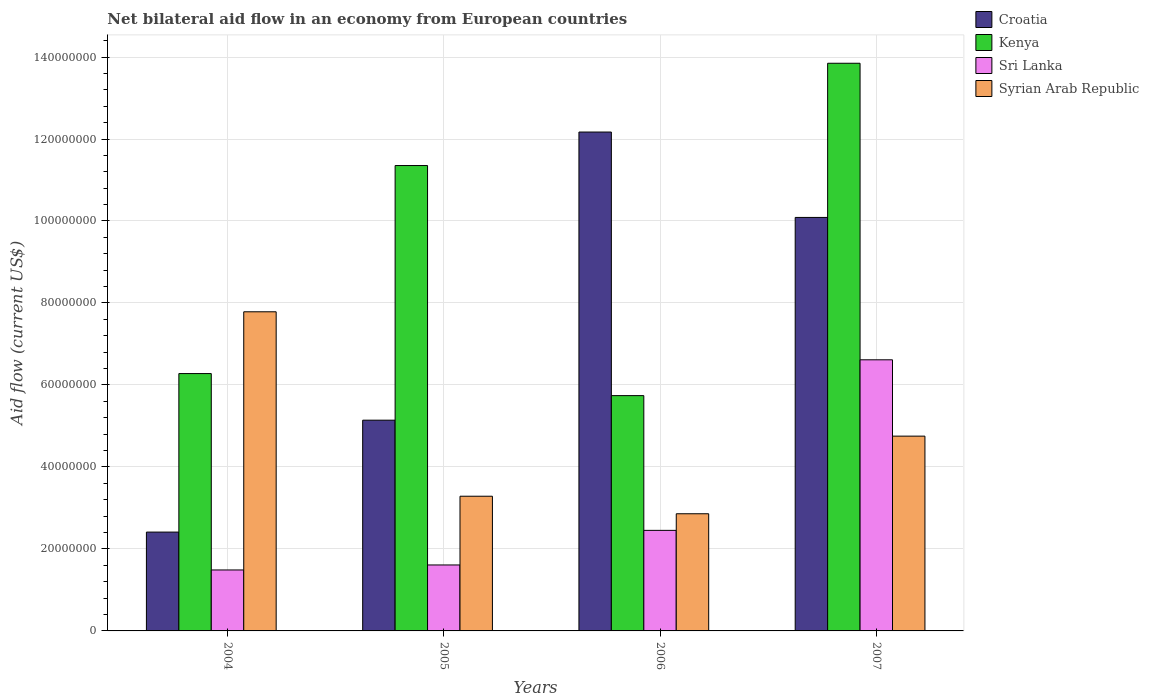How many groups of bars are there?
Provide a short and direct response. 4. Are the number of bars per tick equal to the number of legend labels?
Your answer should be very brief. Yes. Are the number of bars on each tick of the X-axis equal?
Your response must be concise. Yes. How many bars are there on the 1st tick from the right?
Your response must be concise. 4. What is the net bilateral aid flow in Kenya in 2006?
Ensure brevity in your answer.  5.74e+07. Across all years, what is the maximum net bilateral aid flow in Syrian Arab Republic?
Provide a succinct answer. 7.78e+07. Across all years, what is the minimum net bilateral aid flow in Croatia?
Ensure brevity in your answer.  2.41e+07. In which year was the net bilateral aid flow in Croatia maximum?
Keep it short and to the point. 2006. In which year was the net bilateral aid flow in Croatia minimum?
Provide a succinct answer. 2004. What is the total net bilateral aid flow in Croatia in the graph?
Provide a succinct answer. 2.98e+08. What is the difference between the net bilateral aid flow in Kenya in 2005 and that in 2007?
Provide a succinct answer. -2.50e+07. What is the difference between the net bilateral aid flow in Kenya in 2005 and the net bilateral aid flow in Syrian Arab Republic in 2006?
Make the answer very short. 8.50e+07. What is the average net bilateral aid flow in Sri Lanka per year?
Provide a succinct answer. 3.04e+07. In the year 2006, what is the difference between the net bilateral aid flow in Kenya and net bilateral aid flow in Syrian Arab Republic?
Your answer should be compact. 2.88e+07. In how many years, is the net bilateral aid flow in Croatia greater than 4000000 US$?
Provide a succinct answer. 4. What is the ratio of the net bilateral aid flow in Croatia in 2005 to that in 2006?
Give a very brief answer. 0.42. Is the net bilateral aid flow in Kenya in 2005 less than that in 2007?
Give a very brief answer. Yes. Is the difference between the net bilateral aid flow in Kenya in 2005 and 2007 greater than the difference between the net bilateral aid flow in Syrian Arab Republic in 2005 and 2007?
Keep it short and to the point. No. What is the difference between the highest and the second highest net bilateral aid flow in Sri Lanka?
Offer a very short reply. 4.16e+07. What is the difference between the highest and the lowest net bilateral aid flow in Croatia?
Your response must be concise. 9.76e+07. What does the 4th bar from the left in 2007 represents?
Make the answer very short. Syrian Arab Republic. What does the 2nd bar from the right in 2005 represents?
Offer a terse response. Sri Lanka. Is it the case that in every year, the sum of the net bilateral aid flow in Syrian Arab Republic and net bilateral aid flow in Sri Lanka is greater than the net bilateral aid flow in Croatia?
Make the answer very short. No. How many years are there in the graph?
Give a very brief answer. 4. What is the difference between two consecutive major ticks on the Y-axis?
Keep it short and to the point. 2.00e+07. Are the values on the major ticks of Y-axis written in scientific E-notation?
Provide a short and direct response. No. Does the graph contain grids?
Offer a very short reply. Yes. Where does the legend appear in the graph?
Ensure brevity in your answer.  Top right. How are the legend labels stacked?
Your answer should be very brief. Vertical. What is the title of the graph?
Make the answer very short. Net bilateral aid flow in an economy from European countries. What is the label or title of the X-axis?
Make the answer very short. Years. What is the Aid flow (current US$) in Croatia in 2004?
Give a very brief answer. 2.41e+07. What is the Aid flow (current US$) in Kenya in 2004?
Give a very brief answer. 6.28e+07. What is the Aid flow (current US$) of Sri Lanka in 2004?
Offer a very short reply. 1.49e+07. What is the Aid flow (current US$) of Syrian Arab Republic in 2004?
Ensure brevity in your answer.  7.78e+07. What is the Aid flow (current US$) of Croatia in 2005?
Your answer should be compact. 5.14e+07. What is the Aid flow (current US$) of Kenya in 2005?
Make the answer very short. 1.14e+08. What is the Aid flow (current US$) in Sri Lanka in 2005?
Keep it short and to the point. 1.61e+07. What is the Aid flow (current US$) in Syrian Arab Republic in 2005?
Offer a terse response. 3.29e+07. What is the Aid flow (current US$) of Croatia in 2006?
Keep it short and to the point. 1.22e+08. What is the Aid flow (current US$) of Kenya in 2006?
Give a very brief answer. 5.74e+07. What is the Aid flow (current US$) of Sri Lanka in 2006?
Offer a very short reply. 2.45e+07. What is the Aid flow (current US$) in Syrian Arab Republic in 2006?
Your answer should be compact. 2.86e+07. What is the Aid flow (current US$) of Croatia in 2007?
Give a very brief answer. 1.01e+08. What is the Aid flow (current US$) in Kenya in 2007?
Your answer should be compact. 1.38e+08. What is the Aid flow (current US$) in Sri Lanka in 2007?
Provide a short and direct response. 6.61e+07. What is the Aid flow (current US$) of Syrian Arab Republic in 2007?
Keep it short and to the point. 4.75e+07. Across all years, what is the maximum Aid flow (current US$) in Croatia?
Your answer should be compact. 1.22e+08. Across all years, what is the maximum Aid flow (current US$) in Kenya?
Your answer should be very brief. 1.38e+08. Across all years, what is the maximum Aid flow (current US$) of Sri Lanka?
Keep it short and to the point. 6.61e+07. Across all years, what is the maximum Aid flow (current US$) of Syrian Arab Republic?
Make the answer very short. 7.78e+07. Across all years, what is the minimum Aid flow (current US$) of Croatia?
Provide a succinct answer. 2.41e+07. Across all years, what is the minimum Aid flow (current US$) of Kenya?
Ensure brevity in your answer.  5.74e+07. Across all years, what is the minimum Aid flow (current US$) in Sri Lanka?
Your response must be concise. 1.49e+07. Across all years, what is the minimum Aid flow (current US$) of Syrian Arab Republic?
Your response must be concise. 2.86e+07. What is the total Aid flow (current US$) in Croatia in the graph?
Provide a succinct answer. 2.98e+08. What is the total Aid flow (current US$) of Kenya in the graph?
Provide a succinct answer. 3.72e+08. What is the total Aid flow (current US$) in Sri Lanka in the graph?
Your response must be concise. 1.22e+08. What is the total Aid flow (current US$) of Syrian Arab Republic in the graph?
Provide a short and direct response. 1.87e+08. What is the difference between the Aid flow (current US$) of Croatia in 2004 and that in 2005?
Offer a terse response. -2.73e+07. What is the difference between the Aid flow (current US$) in Kenya in 2004 and that in 2005?
Provide a succinct answer. -5.08e+07. What is the difference between the Aid flow (current US$) of Sri Lanka in 2004 and that in 2005?
Keep it short and to the point. -1.22e+06. What is the difference between the Aid flow (current US$) in Syrian Arab Republic in 2004 and that in 2005?
Offer a terse response. 4.50e+07. What is the difference between the Aid flow (current US$) in Croatia in 2004 and that in 2006?
Keep it short and to the point. -9.76e+07. What is the difference between the Aid flow (current US$) in Kenya in 2004 and that in 2006?
Your response must be concise. 5.38e+06. What is the difference between the Aid flow (current US$) of Sri Lanka in 2004 and that in 2006?
Offer a terse response. -9.66e+06. What is the difference between the Aid flow (current US$) of Syrian Arab Republic in 2004 and that in 2006?
Make the answer very short. 4.93e+07. What is the difference between the Aid flow (current US$) in Croatia in 2004 and that in 2007?
Provide a short and direct response. -7.68e+07. What is the difference between the Aid flow (current US$) in Kenya in 2004 and that in 2007?
Your answer should be compact. -7.57e+07. What is the difference between the Aid flow (current US$) in Sri Lanka in 2004 and that in 2007?
Your answer should be compact. -5.13e+07. What is the difference between the Aid flow (current US$) of Syrian Arab Republic in 2004 and that in 2007?
Your response must be concise. 3.03e+07. What is the difference between the Aid flow (current US$) in Croatia in 2005 and that in 2006?
Make the answer very short. -7.03e+07. What is the difference between the Aid flow (current US$) in Kenya in 2005 and that in 2006?
Ensure brevity in your answer.  5.61e+07. What is the difference between the Aid flow (current US$) in Sri Lanka in 2005 and that in 2006?
Give a very brief answer. -8.44e+06. What is the difference between the Aid flow (current US$) in Syrian Arab Republic in 2005 and that in 2006?
Your answer should be compact. 4.28e+06. What is the difference between the Aid flow (current US$) of Croatia in 2005 and that in 2007?
Keep it short and to the point. -4.95e+07. What is the difference between the Aid flow (current US$) of Kenya in 2005 and that in 2007?
Provide a succinct answer. -2.50e+07. What is the difference between the Aid flow (current US$) in Sri Lanka in 2005 and that in 2007?
Provide a succinct answer. -5.00e+07. What is the difference between the Aid flow (current US$) of Syrian Arab Republic in 2005 and that in 2007?
Your answer should be very brief. -1.47e+07. What is the difference between the Aid flow (current US$) in Croatia in 2006 and that in 2007?
Offer a terse response. 2.08e+07. What is the difference between the Aid flow (current US$) of Kenya in 2006 and that in 2007?
Your answer should be compact. -8.11e+07. What is the difference between the Aid flow (current US$) in Sri Lanka in 2006 and that in 2007?
Give a very brief answer. -4.16e+07. What is the difference between the Aid flow (current US$) in Syrian Arab Republic in 2006 and that in 2007?
Your response must be concise. -1.89e+07. What is the difference between the Aid flow (current US$) of Croatia in 2004 and the Aid flow (current US$) of Kenya in 2005?
Your response must be concise. -8.94e+07. What is the difference between the Aid flow (current US$) of Croatia in 2004 and the Aid flow (current US$) of Sri Lanka in 2005?
Make the answer very short. 8.02e+06. What is the difference between the Aid flow (current US$) of Croatia in 2004 and the Aid flow (current US$) of Syrian Arab Republic in 2005?
Offer a terse response. -8.75e+06. What is the difference between the Aid flow (current US$) of Kenya in 2004 and the Aid flow (current US$) of Sri Lanka in 2005?
Give a very brief answer. 4.67e+07. What is the difference between the Aid flow (current US$) of Kenya in 2004 and the Aid flow (current US$) of Syrian Arab Republic in 2005?
Provide a succinct answer. 2.99e+07. What is the difference between the Aid flow (current US$) in Sri Lanka in 2004 and the Aid flow (current US$) in Syrian Arab Republic in 2005?
Offer a terse response. -1.80e+07. What is the difference between the Aid flow (current US$) in Croatia in 2004 and the Aid flow (current US$) in Kenya in 2006?
Offer a terse response. -3.33e+07. What is the difference between the Aid flow (current US$) of Croatia in 2004 and the Aid flow (current US$) of Sri Lanka in 2006?
Give a very brief answer. -4.20e+05. What is the difference between the Aid flow (current US$) of Croatia in 2004 and the Aid flow (current US$) of Syrian Arab Republic in 2006?
Your answer should be compact. -4.47e+06. What is the difference between the Aid flow (current US$) in Kenya in 2004 and the Aid flow (current US$) in Sri Lanka in 2006?
Your response must be concise. 3.82e+07. What is the difference between the Aid flow (current US$) of Kenya in 2004 and the Aid flow (current US$) of Syrian Arab Republic in 2006?
Make the answer very short. 3.42e+07. What is the difference between the Aid flow (current US$) of Sri Lanka in 2004 and the Aid flow (current US$) of Syrian Arab Republic in 2006?
Offer a terse response. -1.37e+07. What is the difference between the Aid flow (current US$) in Croatia in 2004 and the Aid flow (current US$) in Kenya in 2007?
Make the answer very short. -1.14e+08. What is the difference between the Aid flow (current US$) of Croatia in 2004 and the Aid flow (current US$) of Sri Lanka in 2007?
Give a very brief answer. -4.20e+07. What is the difference between the Aid flow (current US$) of Croatia in 2004 and the Aid flow (current US$) of Syrian Arab Republic in 2007?
Ensure brevity in your answer.  -2.34e+07. What is the difference between the Aid flow (current US$) in Kenya in 2004 and the Aid flow (current US$) in Sri Lanka in 2007?
Your answer should be very brief. -3.36e+06. What is the difference between the Aid flow (current US$) of Kenya in 2004 and the Aid flow (current US$) of Syrian Arab Republic in 2007?
Your answer should be very brief. 1.53e+07. What is the difference between the Aid flow (current US$) of Sri Lanka in 2004 and the Aid flow (current US$) of Syrian Arab Republic in 2007?
Your answer should be very brief. -3.26e+07. What is the difference between the Aid flow (current US$) in Croatia in 2005 and the Aid flow (current US$) in Kenya in 2006?
Your answer should be very brief. -5.99e+06. What is the difference between the Aid flow (current US$) of Croatia in 2005 and the Aid flow (current US$) of Sri Lanka in 2006?
Your response must be concise. 2.69e+07. What is the difference between the Aid flow (current US$) in Croatia in 2005 and the Aid flow (current US$) in Syrian Arab Republic in 2006?
Ensure brevity in your answer.  2.28e+07. What is the difference between the Aid flow (current US$) of Kenya in 2005 and the Aid flow (current US$) of Sri Lanka in 2006?
Your answer should be compact. 8.90e+07. What is the difference between the Aid flow (current US$) in Kenya in 2005 and the Aid flow (current US$) in Syrian Arab Republic in 2006?
Offer a very short reply. 8.50e+07. What is the difference between the Aid flow (current US$) of Sri Lanka in 2005 and the Aid flow (current US$) of Syrian Arab Republic in 2006?
Keep it short and to the point. -1.25e+07. What is the difference between the Aid flow (current US$) of Croatia in 2005 and the Aid flow (current US$) of Kenya in 2007?
Provide a succinct answer. -8.71e+07. What is the difference between the Aid flow (current US$) of Croatia in 2005 and the Aid flow (current US$) of Sri Lanka in 2007?
Your response must be concise. -1.47e+07. What is the difference between the Aid flow (current US$) in Croatia in 2005 and the Aid flow (current US$) in Syrian Arab Republic in 2007?
Ensure brevity in your answer.  3.89e+06. What is the difference between the Aid flow (current US$) in Kenya in 2005 and the Aid flow (current US$) in Sri Lanka in 2007?
Offer a very short reply. 4.74e+07. What is the difference between the Aid flow (current US$) of Kenya in 2005 and the Aid flow (current US$) of Syrian Arab Republic in 2007?
Provide a succinct answer. 6.60e+07. What is the difference between the Aid flow (current US$) of Sri Lanka in 2005 and the Aid flow (current US$) of Syrian Arab Republic in 2007?
Ensure brevity in your answer.  -3.14e+07. What is the difference between the Aid flow (current US$) in Croatia in 2006 and the Aid flow (current US$) in Kenya in 2007?
Ensure brevity in your answer.  -1.68e+07. What is the difference between the Aid flow (current US$) in Croatia in 2006 and the Aid flow (current US$) in Sri Lanka in 2007?
Your answer should be compact. 5.56e+07. What is the difference between the Aid flow (current US$) of Croatia in 2006 and the Aid flow (current US$) of Syrian Arab Republic in 2007?
Offer a very short reply. 7.42e+07. What is the difference between the Aid flow (current US$) in Kenya in 2006 and the Aid flow (current US$) in Sri Lanka in 2007?
Provide a succinct answer. -8.74e+06. What is the difference between the Aid flow (current US$) of Kenya in 2006 and the Aid flow (current US$) of Syrian Arab Republic in 2007?
Keep it short and to the point. 9.88e+06. What is the difference between the Aid flow (current US$) in Sri Lanka in 2006 and the Aid flow (current US$) in Syrian Arab Republic in 2007?
Offer a terse response. -2.30e+07. What is the average Aid flow (current US$) in Croatia per year?
Offer a very short reply. 7.45e+07. What is the average Aid flow (current US$) in Kenya per year?
Keep it short and to the point. 9.30e+07. What is the average Aid flow (current US$) in Sri Lanka per year?
Offer a terse response. 3.04e+07. What is the average Aid flow (current US$) of Syrian Arab Republic per year?
Make the answer very short. 4.67e+07. In the year 2004, what is the difference between the Aid flow (current US$) in Croatia and Aid flow (current US$) in Kenya?
Provide a short and direct response. -3.87e+07. In the year 2004, what is the difference between the Aid flow (current US$) in Croatia and Aid flow (current US$) in Sri Lanka?
Provide a short and direct response. 9.24e+06. In the year 2004, what is the difference between the Aid flow (current US$) in Croatia and Aid flow (current US$) in Syrian Arab Republic?
Provide a short and direct response. -5.37e+07. In the year 2004, what is the difference between the Aid flow (current US$) of Kenya and Aid flow (current US$) of Sri Lanka?
Ensure brevity in your answer.  4.79e+07. In the year 2004, what is the difference between the Aid flow (current US$) in Kenya and Aid flow (current US$) in Syrian Arab Republic?
Your answer should be compact. -1.51e+07. In the year 2004, what is the difference between the Aid flow (current US$) in Sri Lanka and Aid flow (current US$) in Syrian Arab Republic?
Make the answer very short. -6.30e+07. In the year 2005, what is the difference between the Aid flow (current US$) of Croatia and Aid flow (current US$) of Kenya?
Offer a terse response. -6.21e+07. In the year 2005, what is the difference between the Aid flow (current US$) in Croatia and Aid flow (current US$) in Sri Lanka?
Provide a short and direct response. 3.53e+07. In the year 2005, what is the difference between the Aid flow (current US$) of Croatia and Aid flow (current US$) of Syrian Arab Republic?
Your answer should be very brief. 1.86e+07. In the year 2005, what is the difference between the Aid flow (current US$) of Kenya and Aid flow (current US$) of Sri Lanka?
Provide a succinct answer. 9.74e+07. In the year 2005, what is the difference between the Aid flow (current US$) in Kenya and Aid flow (current US$) in Syrian Arab Republic?
Keep it short and to the point. 8.07e+07. In the year 2005, what is the difference between the Aid flow (current US$) in Sri Lanka and Aid flow (current US$) in Syrian Arab Republic?
Offer a terse response. -1.68e+07. In the year 2006, what is the difference between the Aid flow (current US$) of Croatia and Aid flow (current US$) of Kenya?
Give a very brief answer. 6.43e+07. In the year 2006, what is the difference between the Aid flow (current US$) in Croatia and Aid flow (current US$) in Sri Lanka?
Offer a terse response. 9.72e+07. In the year 2006, what is the difference between the Aid flow (current US$) of Croatia and Aid flow (current US$) of Syrian Arab Republic?
Keep it short and to the point. 9.31e+07. In the year 2006, what is the difference between the Aid flow (current US$) of Kenya and Aid flow (current US$) of Sri Lanka?
Your answer should be very brief. 3.29e+07. In the year 2006, what is the difference between the Aid flow (current US$) in Kenya and Aid flow (current US$) in Syrian Arab Republic?
Your answer should be very brief. 2.88e+07. In the year 2006, what is the difference between the Aid flow (current US$) in Sri Lanka and Aid flow (current US$) in Syrian Arab Republic?
Give a very brief answer. -4.05e+06. In the year 2007, what is the difference between the Aid flow (current US$) in Croatia and Aid flow (current US$) in Kenya?
Your response must be concise. -3.76e+07. In the year 2007, what is the difference between the Aid flow (current US$) in Croatia and Aid flow (current US$) in Sri Lanka?
Provide a short and direct response. 3.47e+07. In the year 2007, what is the difference between the Aid flow (current US$) in Croatia and Aid flow (current US$) in Syrian Arab Republic?
Provide a short and direct response. 5.34e+07. In the year 2007, what is the difference between the Aid flow (current US$) of Kenya and Aid flow (current US$) of Sri Lanka?
Provide a short and direct response. 7.23e+07. In the year 2007, what is the difference between the Aid flow (current US$) in Kenya and Aid flow (current US$) in Syrian Arab Republic?
Provide a short and direct response. 9.10e+07. In the year 2007, what is the difference between the Aid flow (current US$) of Sri Lanka and Aid flow (current US$) of Syrian Arab Republic?
Give a very brief answer. 1.86e+07. What is the ratio of the Aid flow (current US$) in Croatia in 2004 to that in 2005?
Offer a very short reply. 0.47. What is the ratio of the Aid flow (current US$) of Kenya in 2004 to that in 2005?
Ensure brevity in your answer.  0.55. What is the ratio of the Aid flow (current US$) in Sri Lanka in 2004 to that in 2005?
Provide a succinct answer. 0.92. What is the ratio of the Aid flow (current US$) in Syrian Arab Republic in 2004 to that in 2005?
Offer a terse response. 2.37. What is the ratio of the Aid flow (current US$) in Croatia in 2004 to that in 2006?
Offer a very short reply. 0.2. What is the ratio of the Aid flow (current US$) in Kenya in 2004 to that in 2006?
Your answer should be very brief. 1.09. What is the ratio of the Aid flow (current US$) in Sri Lanka in 2004 to that in 2006?
Your answer should be very brief. 0.61. What is the ratio of the Aid flow (current US$) of Syrian Arab Republic in 2004 to that in 2006?
Give a very brief answer. 2.72. What is the ratio of the Aid flow (current US$) of Croatia in 2004 to that in 2007?
Your response must be concise. 0.24. What is the ratio of the Aid flow (current US$) in Kenya in 2004 to that in 2007?
Keep it short and to the point. 0.45. What is the ratio of the Aid flow (current US$) in Sri Lanka in 2004 to that in 2007?
Your response must be concise. 0.22. What is the ratio of the Aid flow (current US$) in Syrian Arab Republic in 2004 to that in 2007?
Provide a short and direct response. 1.64. What is the ratio of the Aid flow (current US$) of Croatia in 2005 to that in 2006?
Your response must be concise. 0.42. What is the ratio of the Aid flow (current US$) of Kenya in 2005 to that in 2006?
Give a very brief answer. 1.98. What is the ratio of the Aid flow (current US$) in Sri Lanka in 2005 to that in 2006?
Make the answer very short. 0.66. What is the ratio of the Aid flow (current US$) in Syrian Arab Republic in 2005 to that in 2006?
Your answer should be compact. 1.15. What is the ratio of the Aid flow (current US$) in Croatia in 2005 to that in 2007?
Give a very brief answer. 0.51. What is the ratio of the Aid flow (current US$) in Kenya in 2005 to that in 2007?
Offer a very short reply. 0.82. What is the ratio of the Aid flow (current US$) of Sri Lanka in 2005 to that in 2007?
Keep it short and to the point. 0.24. What is the ratio of the Aid flow (current US$) in Syrian Arab Republic in 2005 to that in 2007?
Your response must be concise. 0.69. What is the ratio of the Aid flow (current US$) of Croatia in 2006 to that in 2007?
Provide a succinct answer. 1.21. What is the ratio of the Aid flow (current US$) of Kenya in 2006 to that in 2007?
Give a very brief answer. 0.41. What is the ratio of the Aid flow (current US$) in Sri Lanka in 2006 to that in 2007?
Your answer should be very brief. 0.37. What is the ratio of the Aid flow (current US$) in Syrian Arab Republic in 2006 to that in 2007?
Ensure brevity in your answer.  0.6. What is the difference between the highest and the second highest Aid flow (current US$) of Croatia?
Offer a very short reply. 2.08e+07. What is the difference between the highest and the second highest Aid flow (current US$) in Kenya?
Make the answer very short. 2.50e+07. What is the difference between the highest and the second highest Aid flow (current US$) in Sri Lanka?
Offer a terse response. 4.16e+07. What is the difference between the highest and the second highest Aid flow (current US$) in Syrian Arab Republic?
Offer a terse response. 3.03e+07. What is the difference between the highest and the lowest Aid flow (current US$) of Croatia?
Provide a short and direct response. 9.76e+07. What is the difference between the highest and the lowest Aid flow (current US$) of Kenya?
Ensure brevity in your answer.  8.11e+07. What is the difference between the highest and the lowest Aid flow (current US$) of Sri Lanka?
Make the answer very short. 5.13e+07. What is the difference between the highest and the lowest Aid flow (current US$) of Syrian Arab Republic?
Make the answer very short. 4.93e+07. 